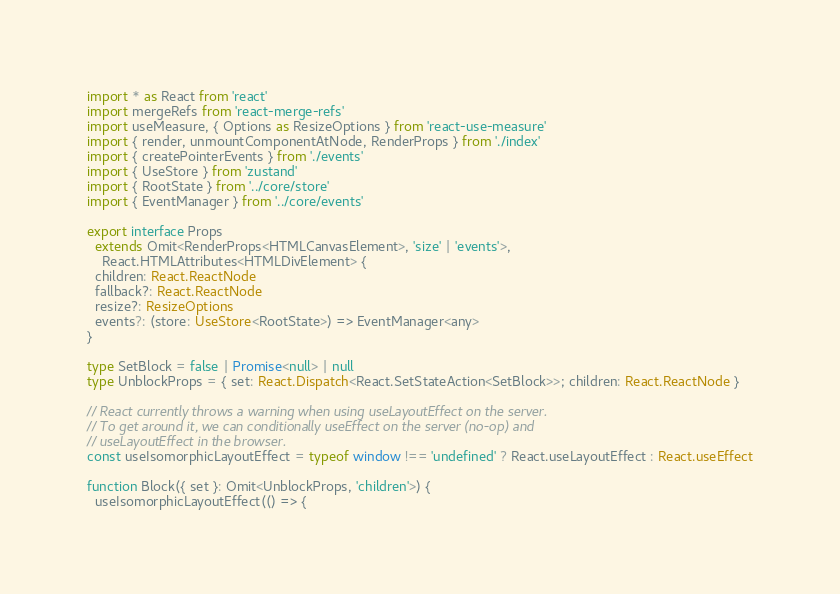<code> <loc_0><loc_0><loc_500><loc_500><_TypeScript_>import * as React from 'react'
import mergeRefs from 'react-merge-refs'
import useMeasure, { Options as ResizeOptions } from 'react-use-measure'
import { render, unmountComponentAtNode, RenderProps } from './index'
import { createPointerEvents } from './events'
import { UseStore } from 'zustand'
import { RootState } from '../core/store'
import { EventManager } from '../core/events'

export interface Props
  extends Omit<RenderProps<HTMLCanvasElement>, 'size' | 'events'>,
    React.HTMLAttributes<HTMLDivElement> {
  children: React.ReactNode
  fallback?: React.ReactNode
  resize?: ResizeOptions
  events?: (store: UseStore<RootState>) => EventManager<any>
}

type SetBlock = false | Promise<null> | null
type UnblockProps = { set: React.Dispatch<React.SetStateAction<SetBlock>>; children: React.ReactNode }

// React currently throws a warning when using useLayoutEffect on the server.
// To get around it, we can conditionally useEffect on the server (no-op) and
// useLayoutEffect in the browser.
const useIsomorphicLayoutEffect = typeof window !== 'undefined' ? React.useLayoutEffect : React.useEffect

function Block({ set }: Omit<UnblockProps, 'children'>) {
  useIsomorphicLayoutEffect(() => {</code> 